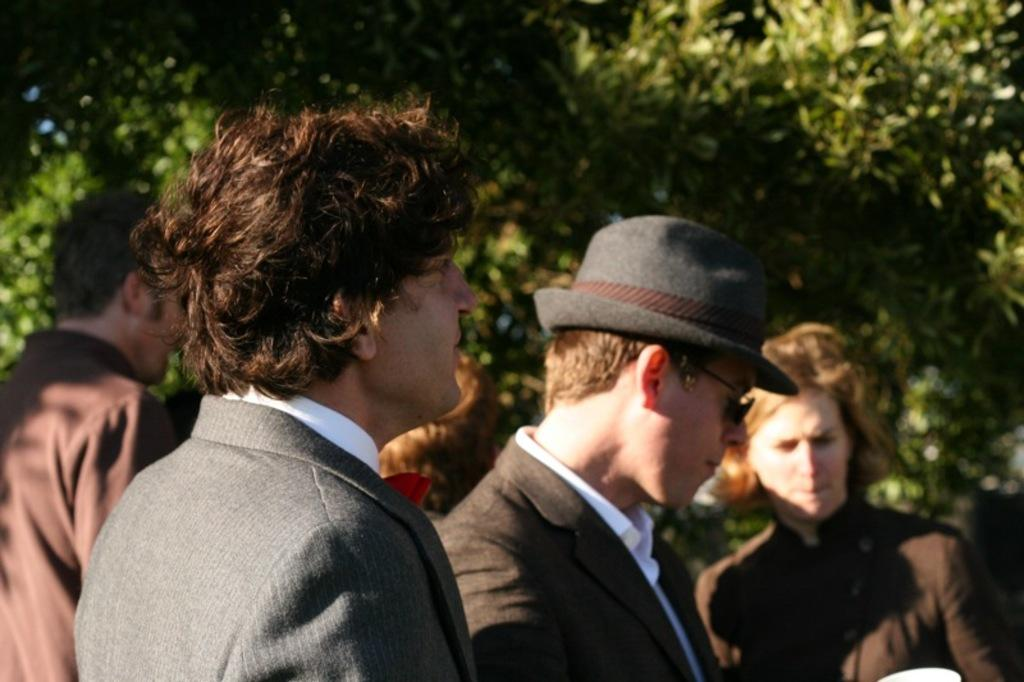Who or what can be seen in the image? There are people in the image. What can be seen in the distance behind the people? There are trees in the background of the image. What type of pipe is being used by the people in the image? There is no pipe visible in the image; it only features people and trees in the background. 